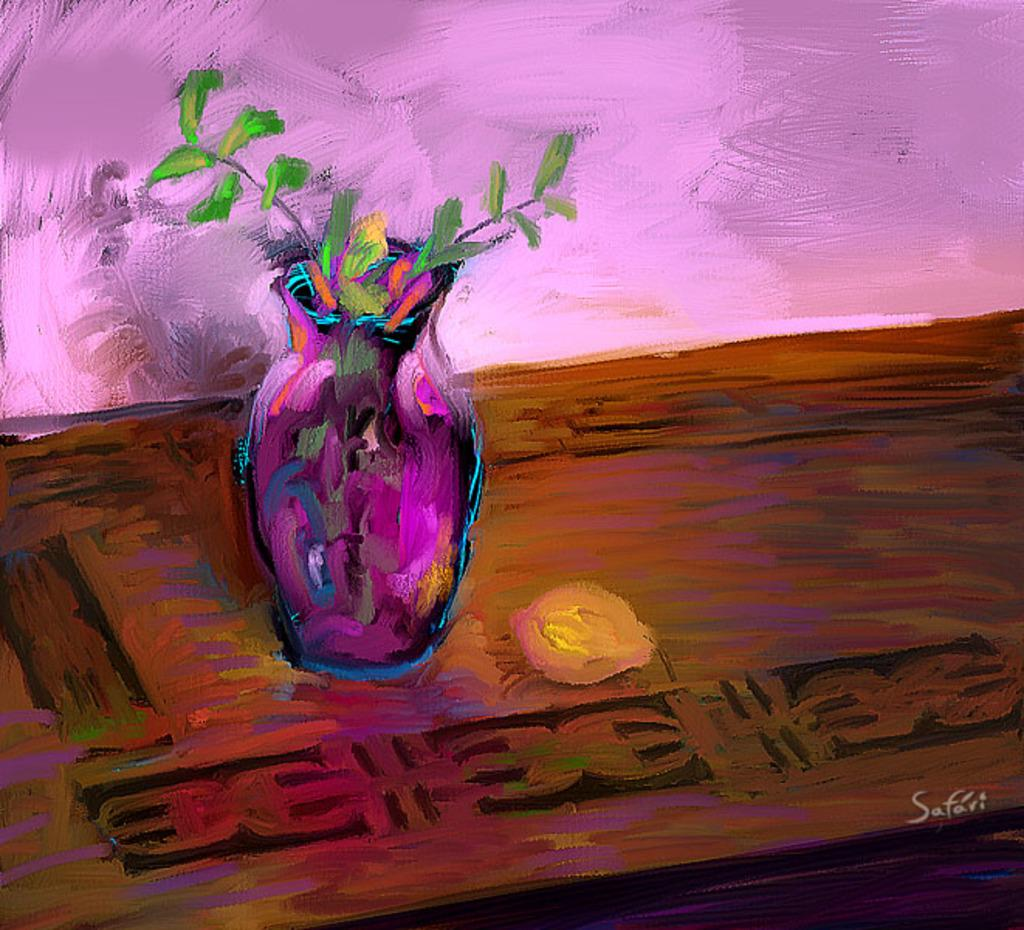What is the main subject of the image? There is a painting in the image. What type of furniture is present in the image? There is a wooden table in the image. What decorative item can be seen on the table? There is a flower vase with flowers in the image. What can be seen in the background of the image? There is a wall in the background of the image. How many passengers are visible in the painting? There are no passengers present in the image, as it features a painting, a wooden table, a flower vase with flowers, and a wall in the background. 